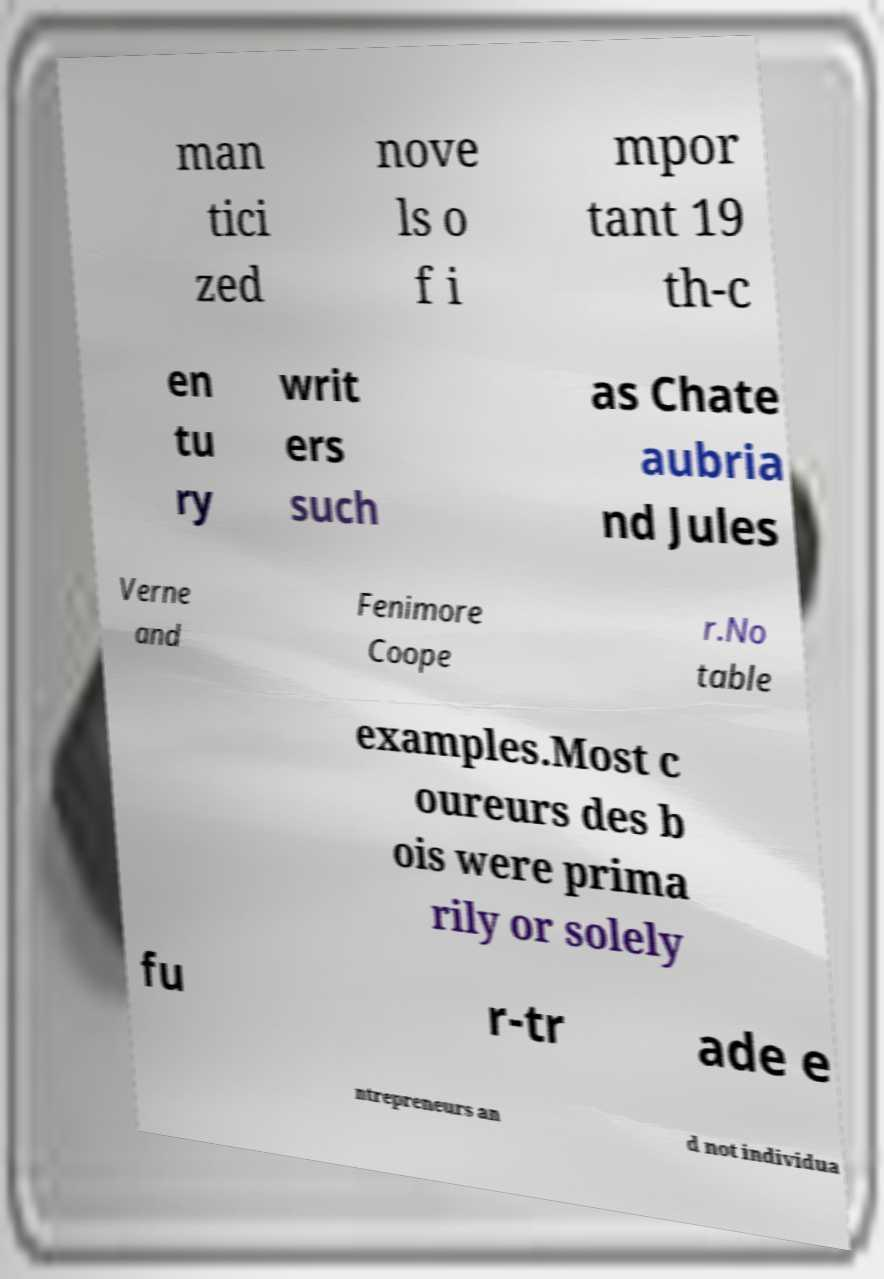There's text embedded in this image that I need extracted. Can you transcribe it verbatim? man tici zed nove ls o f i mpor tant 19 th-c en tu ry writ ers such as Chate aubria nd Jules Verne and Fenimore Coope r.No table examples.Most c oureurs des b ois were prima rily or solely fu r-tr ade e ntrepreneurs an d not individua 